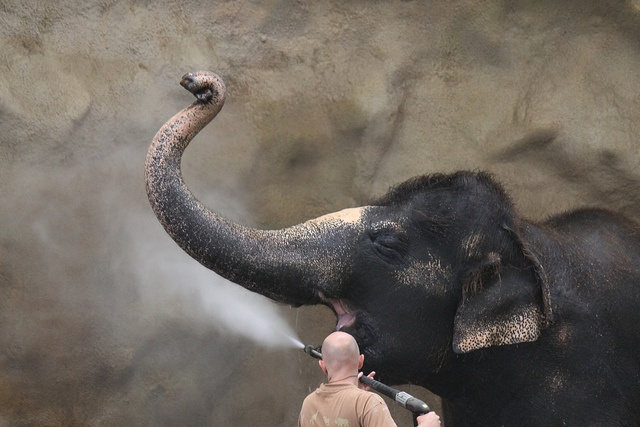Describe the objects in this image and their specific colors. I can see elephant in gray, black, and darkgray tones and people in gray, tan, and darkgray tones in this image. 